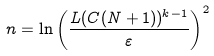<formula> <loc_0><loc_0><loc_500><loc_500>n = \ln \left ( \frac { L ( C ( N + 1 ) ) ^ { k - 1 } } { \varepsilon } \right ) ^ { 2 }</formula> 